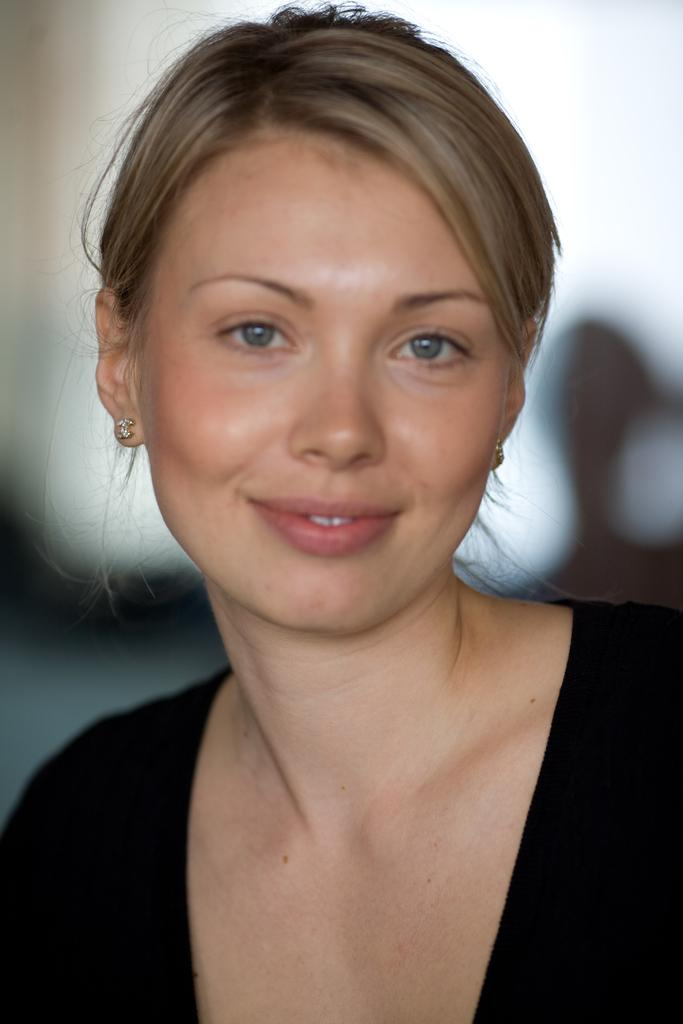Who is the main subject in the image? There is a woman in the image. What is the woman wearing? The woman is wearing a black dress. Can you describe the background of the image? The background of the image is blurred. What impulse did the woman experience before the image was taken? There is no information about the woman's impulses or emotions before the image was taken, so it cannot be determined from the image. 